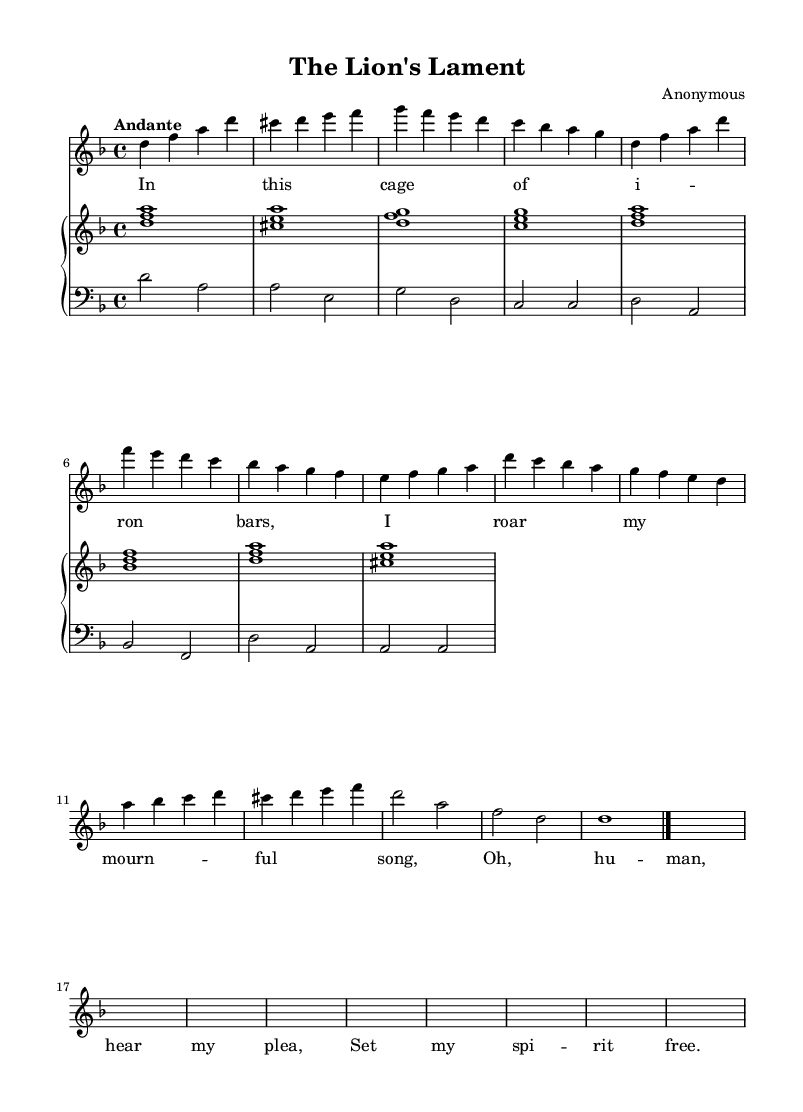What is the key signature of this music? The key signature indicates that this piece is in D minor, as it has one flat (B flat). This can be verified by examining the beginning of the staff where the signature is placed.
Answer: D minor What is the time signature of this music? The time signature is found at the beginning, and it shows that the piece is written in 4/4 time, meaning there are four beats per measure and the quarter note gets one beat.
Answer: 4/4 What tempo marking is indicated for this piece? The tempo marking is located at the beginning of the music, which indicates "Andante," suggesting a moderately slow tempo.
Answer: Andante How many verses are present in the lyrics? The lyrics show a single verse that has been explicitly laid out. The structure of the lyrics indicates that this is designed to repeat, but we only see one verse written.
Answer: One What is the primary emotion expressed in the lyrics? The lyrics convey a sense of sorrow and longing for freedom, reflected in phrases like "I roar my mournful song" and "Set my spirit free." This shows a deep emotional connection to the theme of captivity and desire for liberation.
Answer: Sorrow Which vocal range is indicated for this piece? The music is written for a soprano voice, as denoted by the title 'soprano' in the vocal staff—a range typically used for female voices.
Answer: Soprano What type of accompaniment is used in this piece? The accompaniment consists of a piano, which is organized into a two-hand staff format; this is typical for Baroque music, providing harmonic support to the vocal melody.
Answer: Piano 